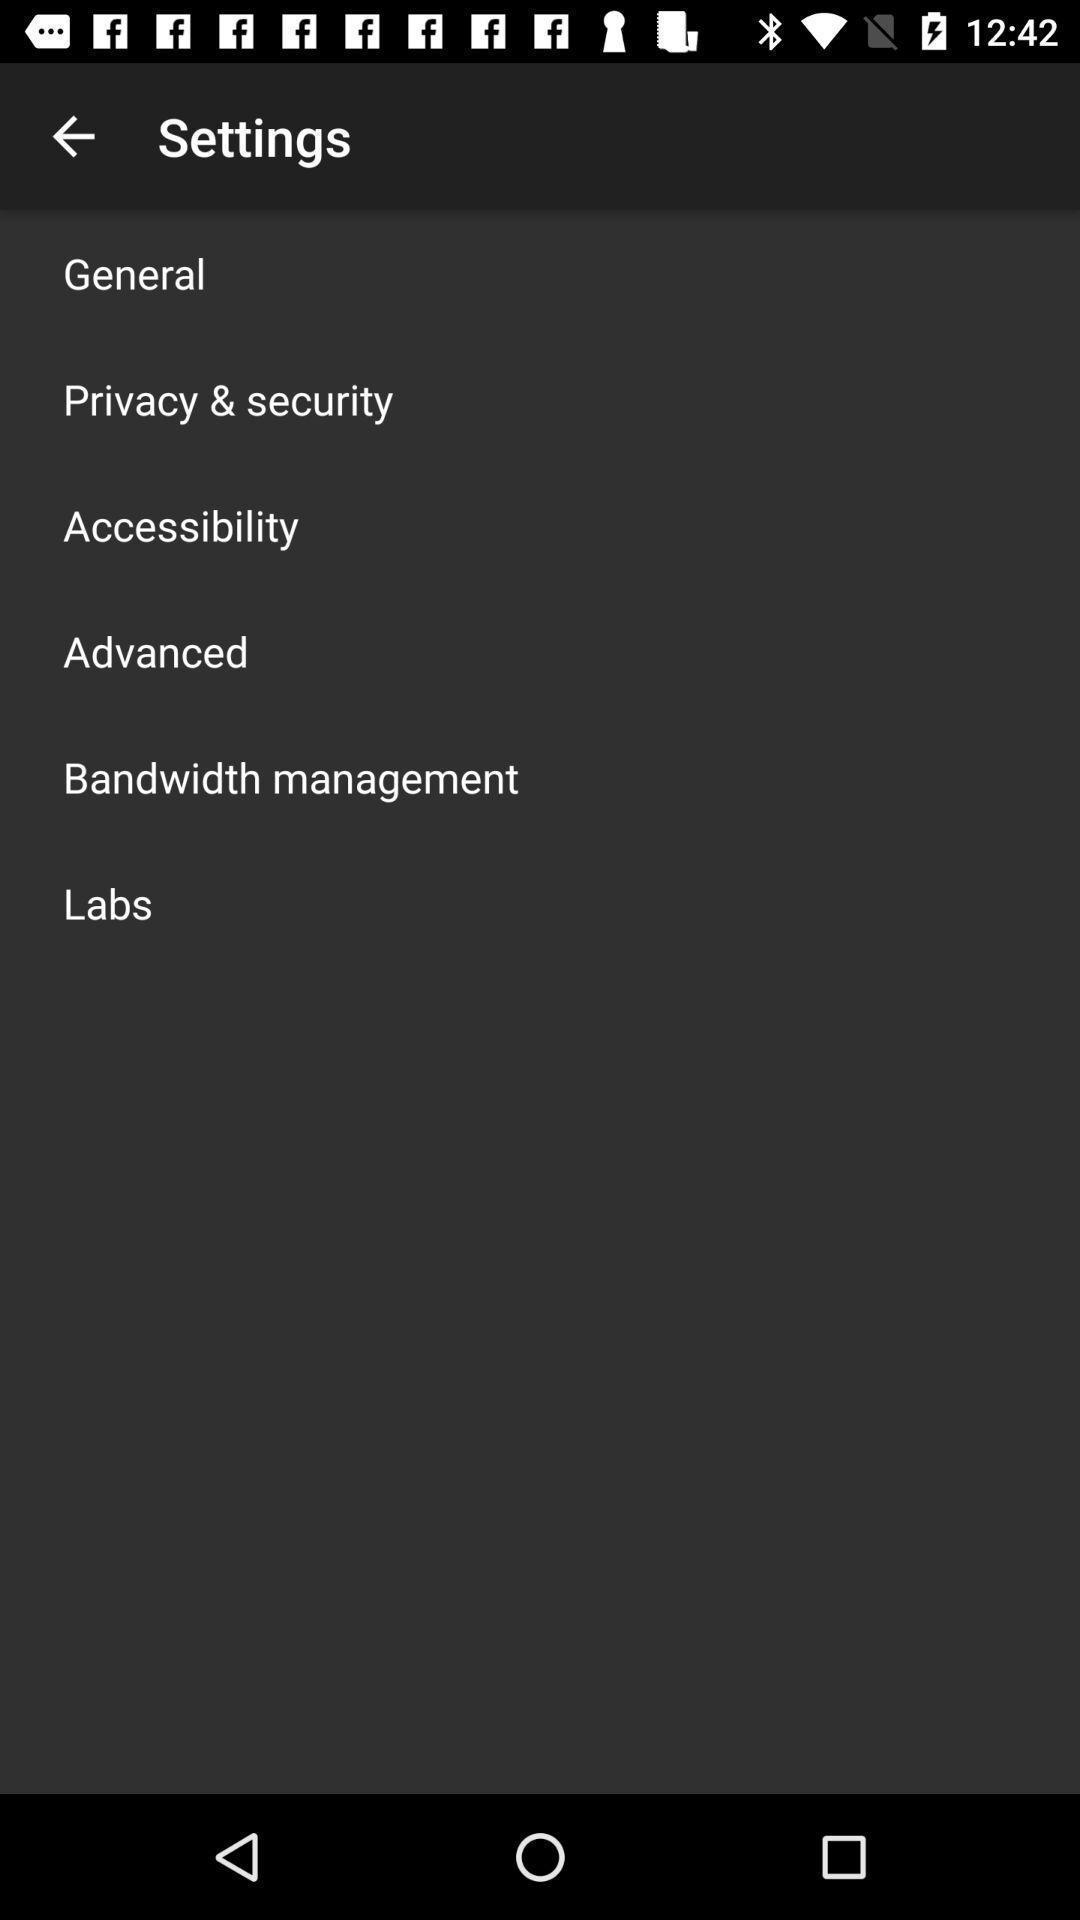Describe this image in words. Settings page. 